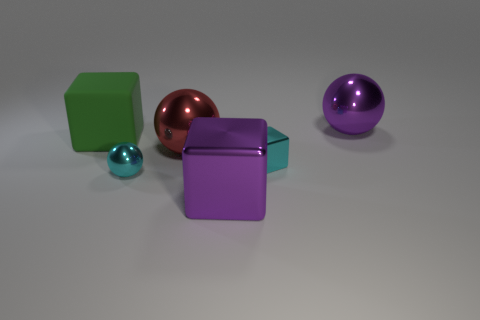There is a tiny object right of the tiny cyan metal sphere that is on the right side of the matte block; what is its material?
Offer a very short reply. Metal. How big is the purple thing that is in front of the cyan metallic thing to the right of the red metallic thing behind the tiny cyan sphere?
Give a very brief answer. Large. Does the large red object have the same shape as the tiny metallic thing to the right of the red shiny object?
Your answer should be compact. No. What is the big red thing made of?
Give a very brief answer. Metal. What number of matte things are either big yellow spheres or big red spheres?
Offer a very short reply. 0. Is the number of large balls that are in front of the large purple cube less than the number of shiny blocks that are on the right side of the small cyan metallic cube?
Your answer should be compact. No. There is a big cube behind the big purple metal object to the left of the big purple metallic sphere; is there a big red metallic ball behind it?
Offer a very short reply. No. There is a tiny cube that is the same color as the tiny metal ball; what material is it?
Your response must be concise. Metal. Is the shape of the big object on the right side of the small metallic cube the same as the big purple object in front of the red metal thing?
Your answer should be very brief. No. What is the material of the purple cube that is the same size as the green object?
Provide a short and direct response. Metal. 